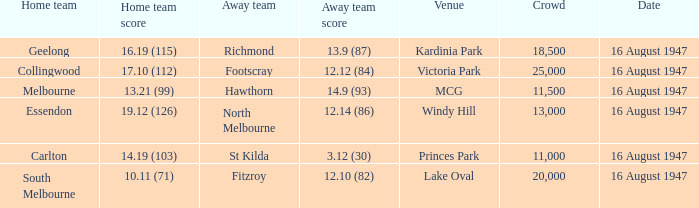What was the total size of the crowd when the away team scored 12.10 (82)? 20000.0. 